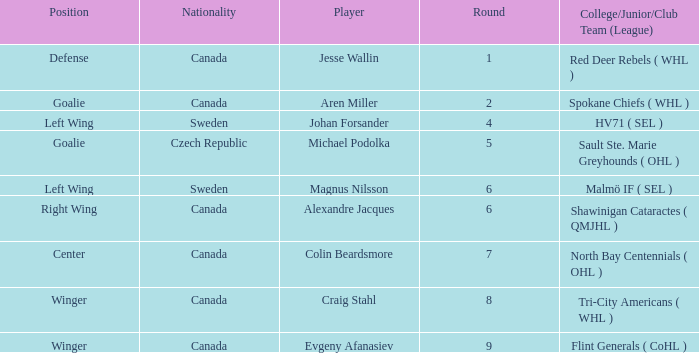What is the School/Junior/Club Group (Association) that has a Round bigger than 6, and a Place of winger, and a Player of evgeny afanasiev? Flint Generals ( CoHL ). 